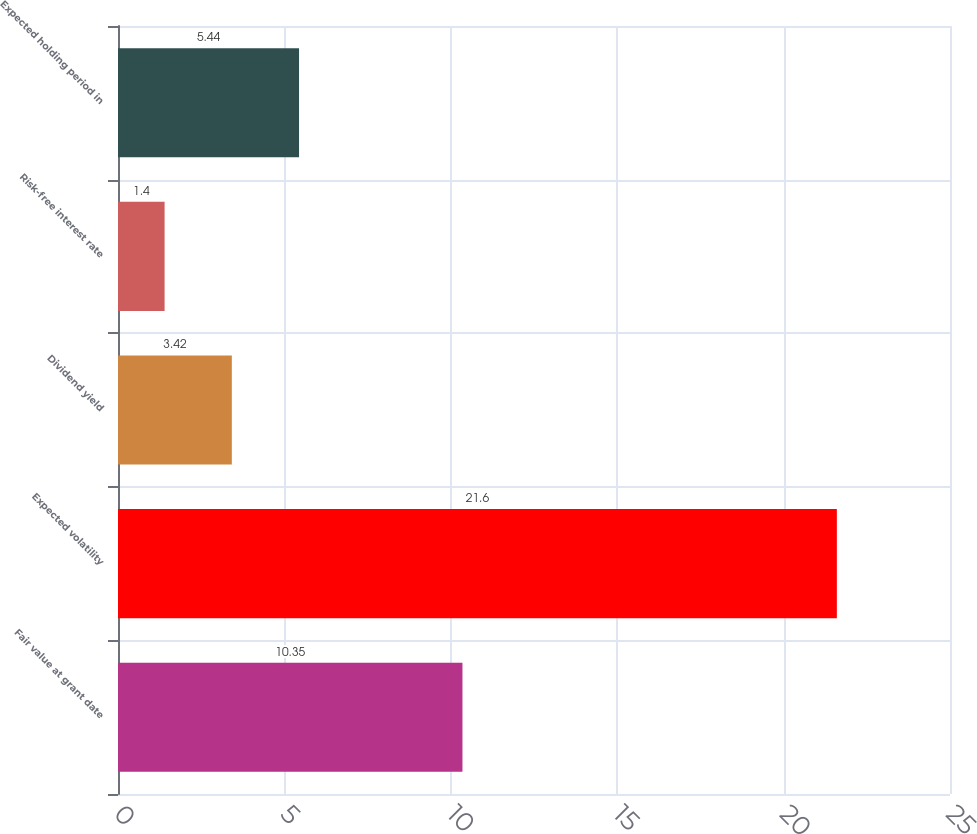<chart> <loc_0><loc_0><loc_500><loc_500><bar_chart><fcel>Fair value at grant date<fcel>Expected volatility<fcel>Dividend yield<fcel>Risk-free interest rate<fcel>Expected holding period in<nl><fcel>10.35<fcel>21.6<fcel>3.42<fcel>1.4<fcel>5.44<nl></chart> 